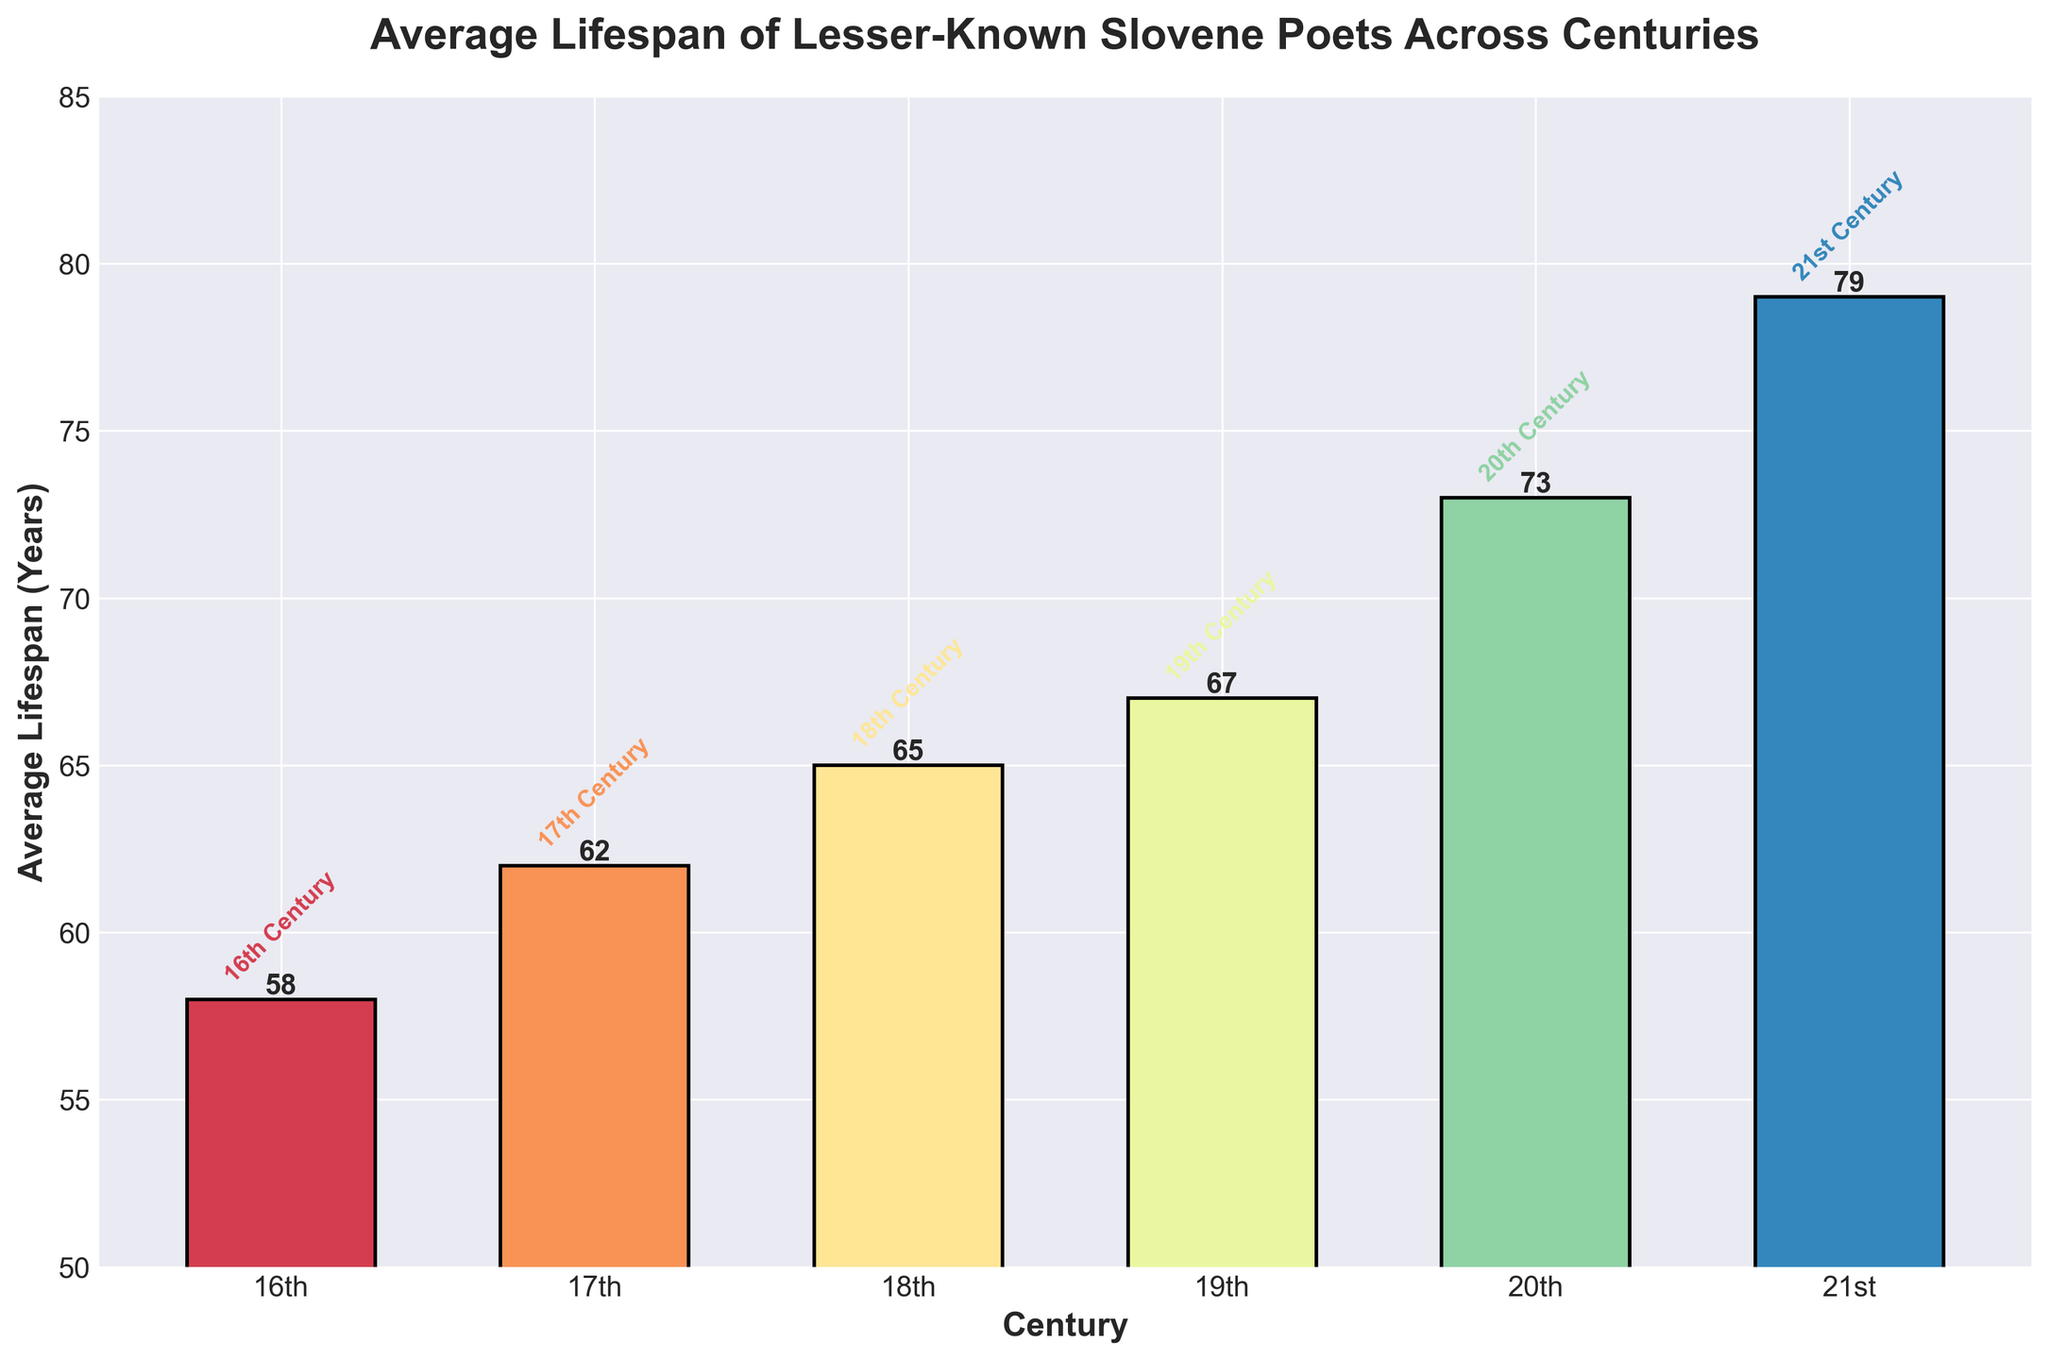Which century had the highest average lifespan for lesser-known Slovene poets? The 21st century has the highest average lifespan of 79 years, as seen from the figure where the bar for the 21st century is the tallest.
Answer: 21st century Which century had the lowest average lifespan for lesser-known Slovene poets? The 16th century has the lowest average lifespan of 58 years, indicated by the shortest bar in the figure.
Answer: 16th century How much has the average lifespan increased from the 16th to the 21st century? The average lifespan in the 16th century was 58 years, and in the 21st century, it is 79 years. The increase is calculated by subtracting 58 from 79, i.e., 79 - 58 = 21 years.
Answer: 21 years Which centuries saw an average lifespan below 70 years? The 16th, 17th, and 18th centuries have average lifespans below 70 years, as indicated by the bars that fall below the 70-year mark on the y-axis.
Answer: 16th, 17th, and 18th centuries How many years did the average lifespan increase from the 19th century to the 21st century? The average lifespan increased from 67 years in the 19th century to 79 years in the 21st century. The increase is calculated by subtracting 67 from 79, i.e., 79 - 67 = 12 years.
Answer: 12 years How does the average lifespan in the 20th century compare to that in the 18th century? The average lifespan in the 20th century is 73 years, while in the 18th century, it is 65 years. The difference is 73 - 65 = 8 years, indicating that the 20th-century lifespan is higher by 8 years.
Answer: The 20th century is higher by 8 years Which century experienced the first significant jump (≥ 5 years) in average lifespan compared to the previous century? The first significant jump is from the 17th to the 18th century, where the lifespan increased from 62 years to 65 years, which is a 3-year difference. The next significant jump is from the 18th to the 19th century with an increase of 2 years. The major jump (≥ 5 years) occurs from the 19th to 20th century, given by an increase from 67 to 73 years (6 years).
Answer: 19th to 20th century Which century has a bar colored closest to red? The color of the bar closest to red, i.e., somewhere between red and orange, is seen for the 16th century in the spectral color map.
Answer: 16th century What is the difference in average lifespan between the 17th and 18th centuries? The average lifespan in the 17th century is 62 years, and in the 18th century, it is 65 years. The difference is calculated by subtracting 62 from 65, i.e., 65 - 62 = 3 years.
Answer: 3 years 